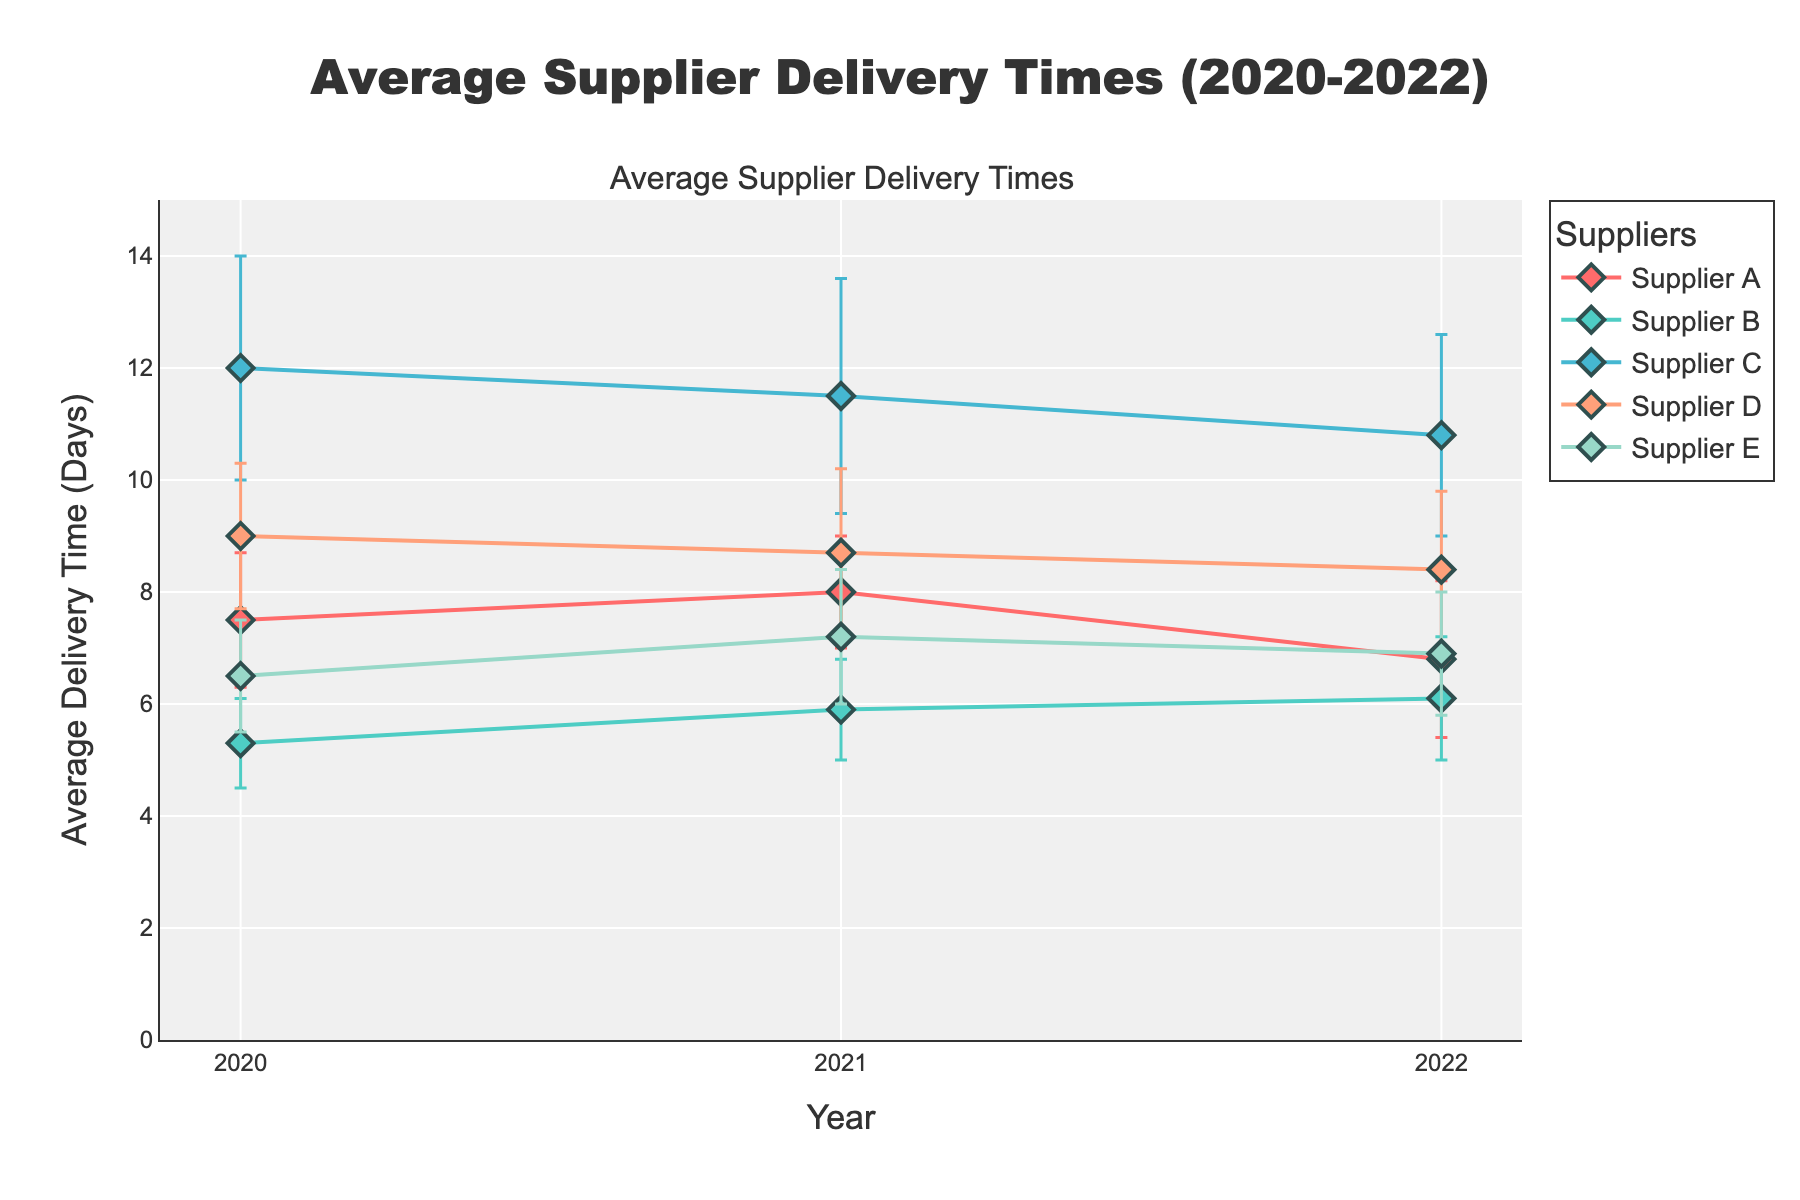what is the title of the plot? The title of the plot is determined by the large, centered text at the top of the figure. The title is "Average Supplier Delivery Times (2020-2022)" which succinctly describes the content of the plot.
Answer: Average Supplier Delivery Times (2020-2022) What is the range of the y-axis? The range of the y-axis can be identified by looking at the lowest and highest values on the vertical axis labeled "Average Delivery Time (Days)". The range is from 0 to 15 days.
Answer: 0 to 15 Compare Supplier A and Supplier B in 2020. Which one has a lower average delivery time and by how many days? Supplier A has an average delivery time of 7.5 days, while Supplier B has 5.3 days in 2020. To find the difference, subtract the smaller value from the larger value: 7.5 - 5.3 = 2.2 days. Supplier B is faster by 2.2 days.
Answer: Supplier B; 2.2 days Which supplier consistently shows the greatest error margin over the years? By comparing the error margins (vertical lines on data points) for each supplier over the years, Supplier C consistently has the largest error margins, ranging around 2.0 to 2.1 days.
Answer: Supplier C What is the trend in average delivery time for Supplier D from 2020 to 2022? Supplier D's average delivery time decreases each year from 9.0 in 2020, 8.7 in 2021, to 8.4 in 2022, showing an overall decreasing trend.
Answer: Decreasing Does any supplier show an increase in average delivery time from 2021 to 2022? By examining the plots, only Supplier B shows an increase in average delivery time from 2021 (5.9 days) to 2022 (6.1 days).
Answer: Supplier B Between Supplier E and Supplier A, which had the largest decrease in average delivery time from 2021 to 2022? For Supplier E, the average delivery time decreased from 7.2 days in 2021 to 6.9 days in 2022. For Supplier A, it decreased from 8.0 to 6.8 days. Calculate the decreases: Supplier A: 8.0 - 6.8 = 1.2 days, Supplier E: 7.2 - 6.9 = 0.3 days. Thus, Supplier A had the largest decrease.
Answer: Supplier A Considering the error margins, can we confidently say Supplier B had a lower average delivery time than Supplier A in 2021? Supplier A's average delivery time in 2021 is 8.0 ± 1.0 days, ranging from 7.0 to 9.0 days. Supplier B's delivery time in 2021 is 5.9 ± 0.9 days, ranging from 5.0 to 6.8 days. Since the ranges do not overlap, we can confidently say that Supplier B had a lower average delivery time.
Answer: Yes Which year had the highest average delivery time for Supplier C and what was the value? Looking at the plot points for Supplier C, 2020 had the highest average delivery time of 12.0 days.
Answer: 2020; 12.0 days 